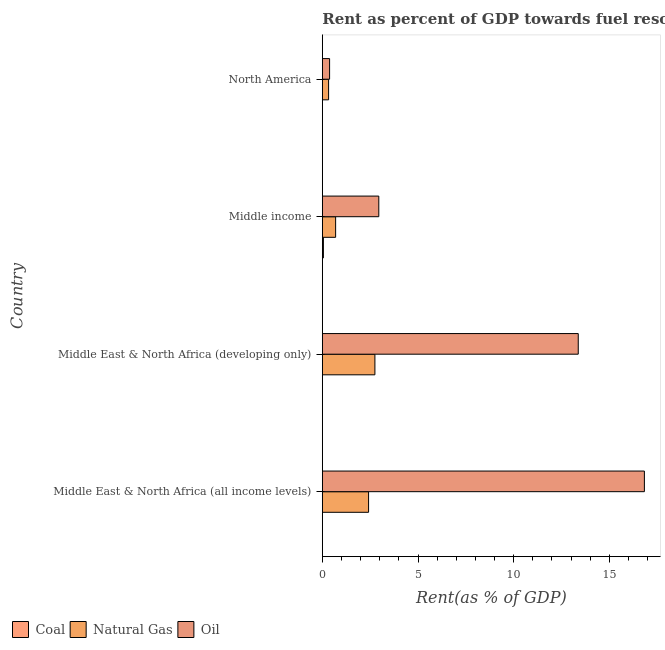How many groups of bars are there?
Your answer should be very brief. 4. How many bars are there on the 1st tick from the bottom?
Keep it short and to the point. 3. What is the label of the 4th group of bars from the top?
Provide a short and direct response. Middle East & North Africa (all income levels). What is the rent towards coal in North America?
Your answer should be very brief. 0. Across all countries, what is the maximum rent towards oil?
Your answer should be very brief. 16.83. Across all countries, what is the minimum rent towards oil?
Your answer should be compact. 0.38. In which country was the rent towards oil maximum?
Ensure brevity in your answer.  Middle East & North Africa (all income levels). In which country was the rent towards coal minimum?
Give a very brief answer. Middle East & North Africa (all income levels). What is the total rent towards coal in the graph?
Your answer should be compact. 0.06. What is the difference between the rent towards natural gas in Middle East & North Africa (all income levels) and that in Middle income?
Make the answer very short. 1.72. What is the difference between the rent towards oil in Middle income and the rent towards coal in Middle East & North Africa (developing only)?
Your answer should be compact. 2.95. What is the average rent towards natural gas per country?
Provide a short and direct response. 1.55. What is the difference between the rent towards oil and rent towards natural gas in Middle East & North Africa (developing only)?
Provide a short and direct response. 10.63. In how many countries, is the rent towards coal greater than 7 %?
Give a very brief answer. 0. What is the ratio of the rent towards oil in Middle income to that in North America?
Your response must be concise. 7.77. Is the difference between the rent towards oil in Middle East & North Africa (all income levels) and Middle income greater than the difference between the rent towards natural gas in Middle East & North Africa (all income levels) and Middle income?
Keep it short and to the point. Yes. What is the difference between the highest and the second highest rent towards oil?
Your answer should be compact. 3.46. In how many countries, is the rent towards coal greater than the average rent towards coal taken over all countries?
Keep it short and to the point. 1. Is the sum of the rent towards oil in Middle East & North Africa (all income levels) and Middle East & North Africa (developing only) greater than the maximum rent towards coal across all countries?
Make the answer very short. Yes. What does the 2nd bar from the top in Middle income represents?
Keep it short and to the point. Natural Gas. What does the 3rd bar from the bottom in North America represents?
Your answer should be very brief. Oil. How many bars are there?
Your answer should be very brief. 12. Are all the bars in the graph horizontal?
Your answer should be compact. Yes. How many countries are there in the graph?
Offer a very short reply. 4. Are the values on the major ticks of X-axis written in scientific E-notation?
Make the answer very short. No. Where does the legend appear in the graph?
Keep it short and to the point. Bottom left. What is the title of the graph?
Provide a short and direct response. Rent as percent of GDP towards fuel resources of different countries in 1997. Does "Labor Tax" appear as one of the legend labels in the graph?
Your answer should be very brief. No. What is the label or title of the X-axis?
Your answer should be very brief. Rent(as % of GDP). What is the Rent(as % of GDP) of Coal in Middle East & North Africa (all income levels)?
Provide a short and direct response. 0. What is the Rent(as % of GDP) of Natural Gas in Middle East & North Africa (all income levels)?
Offer a terse response. 2.42. What is the Rent(as % of GDP) in Oil in Middle East & North Africa (all income levels)?
Keep it short and to the point. 16.83. What is the Rent(as % of GDP) of Coal in Middle East & North Africa (developing only)?
Ensure brevity in your answer.  0. What is the Rent(as % of GDP) of Natural Gas in Middle East & North Africa (developing only)?
Offer a terse response. 2.75. What is the Rent(as % of GDP) of Oil in Middle East & North Africa (developing only)?
Give a very brief answer. 13.37. What is the Rent(as % of GDP) in Coal in Middle income?
Keep it short and to the point. 0.06. What is the Rent(as % of GDP) in Natural Gas in Middle income?
Give a very brief answer. 0.69. What is the Rent(as % of GDP) of Oil in Middle income?
Offer a terse response. 2.95. What is the Rent(as % of GDP) in Coal in North America?
Give a very brief answer. 0. What is the Rent(as % of GDP) in Natural Gas in North America?
Give a very brief answer. 0.33. What is the Rent(as % of GDP) of Oil in North America?
Make the answer very short. 0.38. Across all countries, what is the maximum Rent(as % of GDP) of Coal?
Provide a succinct answer. 0.06. Across all countries, what is the maximum Rent(as % of GDP) in Natural Gas?
Ensure brevity in your answer.  2.75. Across all countries, what is the maximum Rent(as % of GDP) of Oil?
Offer a very short reply. 16.83. Across all countries, what is the minimum Rent(as % of GDP) in Coal?
Your answer should be very brief. 0. Across all countries, what is the minimum Rent(as % of GDP) of Natural Gas?
Your answer should be very brief. 0.33. Across all countries, what is the minimum Rent(as % of GDP) of Oil?
Give a very brief answer. 0.38. What is the total Rent(as % of GDP) of Coal in the graph?
Make the answer very short. 0.06. What is the total Rent(as % of GDP) in Natural Gas in the graph?
Give a very brief answer. 6.19. What is the total Rent(as % of GDP) in Oil in the graph?
Give a very brief answer. 33.53. What is the difference between the Rent(as % of GDP) in Coal in Middle East & North Africa (all income levels) and that in Middle East & North Africa (developing only)?
Give a very brief answer. -0. What is the difference between the Rent(as % of GDP) of Natural Gas in Middle East & North Africa (all income levels) and that in Middle East & North Africa (developing only)?
Offer a terse response. -0.33. What is the difference between the Rent(as % of GDP) of Oil in Middle East & North Africa (all income levels) and that in Middle East & North Africa (developing only)?
Provide a succinct answer. 3.46. What is the difference between the Rent(as % of GDP) in Coal in Middle East & North Africa (all income levels) and that in Middle income?
Keep it short and to the point. -0.06. What is the difference between the Rent(as % of GDP) of Natural Gas in Middle East & North Africa (all income levels) and that in Middle income?
Give a very brief answer. 1.72. What is the difference between the Rent(as % of GDP) of Oil in Middle East & North Africa (all income levels) and that in Middle income?
Offer a very short reply. 13.88. What is the difference between the Rent(as % of GDP) of Coal in Middle East & North Africa (all income levels) and that in North America?
Your answer should be very brief. -0. What is the difference between the Rent(as % of GDP) of Natural Gas in Middle East & North Africa (all income levels) and that in North America?
Provide a succinct answer. 2.09. What is the difference between the Rent(as % of GDP) of Oil in Middle East & North Africa (all income levels) and that in North America?
Offer a terse response. 16.45. What is the difference between the Rent(as % of GDP) of Coal in Middle East & North Africa (developing only) and that in Middle income?
Your response must be concise. -0.05. What is the difference between the Rent(as % of GDP) in Natural Gas in Middle East & North Africa (developing only) and that in Middle income?
Your answer should be compact. 2.05. What is the difference between the Rent(as % of GDP) of Oil in Middle East & North Africa (developing only) and that in Middle income?
Provide a short and direct response. 10.42. What is the difference between the Rent(as % of GDP) of Coal in Middle East & North Africa (developing only) and that in North America?
Keep it short and to the point. -0. What is the difference between the Rent(as % of GDP) in Natural Gas in Middle East & North Africa (developing only) and that in North America?
Give a very brief answer. 2.42. What is the difference between the Rent(as % of GDP) in Oil in Middle East & North Africa (developing only) and that in North America?
Your answer should be very brief. 12.99. What is the difference between the Rent(as % of GDP) in Coal in Middle income and that in North America?
Give a very brief answer. 0.05. What is the difference between the Rent(as % of GDP) of Natural Gas in Middle income and that in North America?
Your response must be concise. 0.37. What is the difference between the Rent(as % of GDP) of Oil in Middle income and that in North America?
Your answer should be compact. 2.57. What is the difference between the Rent(as % of GDP) of Coal in Middle East & North Africa (all income levels) and the Rent(as % of GDP) of Natural Gas in Middle East & North Africa (developing only)?
Give a very brief answer. -2.75. What is the difference between the Rent(as % of GDP) in Coal in Middle East & North Africa (all income levels) and the Rent(as % of GDP) in Oil in Middle East & North Africa (developing only)?
Make the answer very short. -13.37. What is the difference between the Rent(as % of GDP) in Natural Gas in Middle East & North Africa (all income levels) and the Rent(as % of GDP) in Oil in Middle East & North Africa (developing only)?
Your answer should be very brief. -10.96. What is the difference between the Rent(as % of GDP) of Coal in Middle East & North Africa (all income levels) and the Rent(as % of GDP) of Natural Gas in Middle income?
Your answer should be compact. -0.69. What is the difference between the Rent(as % of GDP) of Coal in Middle East & North Africa (all income levels) and the Rent(as % of GDP) of Oil in Middle income?
Provide a succinct answer. -2.95. What is the difference between the Rent(as % of GDP) in Natural Gas in Middle East & North Africa (all income levels) and the Rent(as % of GDP) in Oil in Middle income?
Provide a short and direct response. -0.53. What is the difference between the Rent(as % of GDP) of Coal in Middle East & North Africa (all income levels) and the Rent(as % of GDP) of Natural Gas in North America?
Your answer should be very brief. -0.33. What is the difference between the Rent(as % of GDP) of Coal in Middle East & North Africa (all income levels) and the Rent(as % of GDP) of Oil in North America?
Ensure brevity in your answer.  -0.38. What is the difference between the Rent(as % of GDP) in Natural Gas in Middle East & North Africa (all income levels) and the Rent(as % of GDP) in Oil in North America?
Offer a very short reply. 2.04. What is the difference between the Rent(as % of GDP) of Coal in Middle East & North Africa (developing only) and the Rent(as % of GDP) of Natural Gas in Middle income?
Offer a terse response. -0.69. What is the difference between the Rent(as % of GDP) in Coal in Middle East & North Africa (developing only) and the Rent(as % of GDP) in Oil in Middle income?
Ensure brevity in your answer.  -2.95. What is the difference between the Rent(as % of GDP) of Natural Gas in Middle East & North Africa (developing only) and the Rent(as % of GDP) of Oil in Middle income?
Your answer should be very brief. -0.2. What is the difference between the Rent(as % of GDP) in Coal in Middle East & North Africa (developing only) and the Rent(as % of GDP) in Natural Gas in North America?
Ensure brevity in your answer.  -0.33. What is the difference between the Rent(as % of GDP) of Coal in Middle East & North Africa (developing only) and the Rent(as % of GDP) of Oil in North America?
Your response must be concise. -0.38. What is the difference between the Rent(as % of GDP) in Natural Gas in Middle East & North Africa (developing only) and the Rent(as % of GDP) in Oil in North America?
Provide a short and direct response. 2.37. What is the difference between the Rent(as % of GDP) in Coal in Middle income and the Rent(as % of GDP) in Natural Gas in North America?
Provide a succinct answer. -0.27. What is the difference between the Rent(as % of GDP) in Coal in Middle income and the Rent(as % of GDP) in Oil in North America?
Ensure brevity in your answer.  -0.32. What is the difference between the Rent(as % of GDP) of Natural Gas in Middle income and the Rent(as % of GDP) of Oil in North America?
Offer a terse response. 0.32. What is the average Rent(as % of GDP) in Coal per country?
Make the answer very short. 0.02. What is the average Rent(as % of GDP) of Natural Gas per country?
Your response must be concise. 1.55. What is the average Rent(as % of GDP) of Oil per country?
Provide a succinct answer. 8.38. What is the difference between the Rent(as % of GDP) of Coal and Rent(as % of GDP) of Natural Gas in Middle East & North Africa (all income levels)?
Your response must be concise. -2.42. What is the difference between the Rent(as % of GDP) in Coal and Rent(as % of GDP) in Oil in Middle East & North Africa (all income levels)?
Ensure brevity in your answer.  -16.83. What is the difference between the Rent(as % of GDP) of Natural Gas and Rent(as % of GDP) of Oil in Middle East & North Africa (all income levels)?
Offer a very short reply. -14.41. What is the difference between the Rent(as % of GDP) of Coal and Rent(as % of GDP) of Natural Gas in Middle East & North Africa (developing only)?
Offer a very short reply. -2.75. What is the difference between the Rent(as % of GDP) in Coal and Rent(as % of GDP) in Oil in Middle East & North Africa (developing only)?
Give a very brief answer. -13.37. What is the difference between the Rent(as % of GDP) in Natural Gas and Rent(as % of GDP) in Oil in Middle East & North Africa (developing only)?
Your response must be concise. -10.63. What is the difference between the Rent(as % of GDP) in Coal and Rent(as % of GDP) in Natural Gas in Middle income?
Your answer should be compact. -0.64. What is the difference between the Rent(as % of GDP) in Coal and Rent(as % of GDP) in Oil in Middle income?
Provide a succinct answer. -2.9. What is the difference between the Rent(as % of GDP) of Natural Gas and Rent(as % of GDP) of Oil in Middle income?
Provide a short and direct response. -2.26. What is the difference between the Rent(as % of GDP) of Coal and Rent(as % of GDP) of Natural Gas in North America?
Your answer should be compact. -0.32. What is the difference between the Rent(as % of GDP) of Coal and Rent(as % of GDP) of Oil in North America?
Make the answer very short. -0.37. What is the difference between the Rent(as % of GDP) of Natural Gas and Rent(as % of GDP) of Oil in North America?
Offer a terse response. -0.05. What is the ratio of the Rent(as % of GDP) in Coal in Middle East & North Africa (all income levels) to that in Middle East & North Africa (developing only)?
Provide a succinct answer. 0.47. What is the ratio of the Rent(as % of GDP) of Natural Gas in Middle East & North Africa (all income levels) to that in Middle East & North Africa (developing only)?
Provide a short and direct response. 0.88. What is the ratio of the Rent(as % of GDP) in Oil in Middle East & North Africa (all income levels) to that in Middle East & North Africa (developing only)?
Give a very brief answer. 1.26. What is the ratio of the Rent(as % of GDP) of Coal in Middle East & North Africa (all income levels) to that in Middle income?
Provide a succinct answer. 0.02. What is the ratio of the Rent(as % of GDP) in Natural Gas in Middle East & North Africa (all income levels) to that in Middle income?
Your response must be concise. 3.48. What is the ratio of the Rent(as % of GDP) in Oil in Middle East & North Africa (all income levels) to that in Middle income?
Make the answer very short. 5.7. What is the ratio of the Rent(as % of GDP) of Coal in Middle East & North Africa (all income levels) to that in North America?
Offer a terse response. 0.2. What is the ratio of the Rent(as % of GDP) of Natural Gas in Middle East & North Africa (all income levels) to that in North America?
Give a very brief answer. 7.38. What is the ratio of the Rent(as % of GDP) in Oil in Middle East & North Africa (all income levels) to that in North America?
Offer a terse response. 44.34. What is the ratio of the Rent(as % of GDP) in Coal in Middle East & North Africa (developing only) to that in Middle income?
Keep it short and to the point. 0.04. What is the ratio of the Rent(as % of GDP) of Natural Gas in Middle East & North Africa (developing only) to that in Middle income?
Keep it short and to the point. 3.95. What is the ratio of the Rent(as % of GDP) in Oil in Middle East & North Africa (developing only) to that in Middle income?
Ensure brevity in your answer.  4.53. What is the ratio of the Rent(as % of GDP) of Coal in Middle East & North Africa (developing only) to that in North America?
Provide a succinct answer. 0.42. What is the ratio of the Rent(as % of GDP) of Natural Gas in Middle East & North Africa (developing only) to that in North America?
Ensure brevity in your answer.  8.38. What is the ratio of the Rent(as % of GDP) of Oil in Middle East & North Africa (developing only) to that in North America?
Your answer should be compact. 35.23. What is the ratio of the Rent(as % of GDP) of Coal in Middle income to that in North America?
Your answer should be compact. 11.85. What is the ratio of the Rent(as % of GDP) of Natural Gas in Middle income to that in North America?
Offer a very short reply. 2.12. What is the ratio of the Rent(as % of GDP) of Oil in Middle income to that in North America?
Keep it short and to the point. 7.77. What is the difference between the highest and the second highest Rent(as % of GDP) of Coal?
Keep it short and to the point. 0.05. What is the difference between the highest and the second highest Rent(as % of GDP) of Natural Gas?
Provide a succinct answer. 0.33. What is the difference between the highest and the second highest Rent(as % of GDP) in Oil?
Give a very brief answer. 3.46. What is the difference between the highest and the lowest Rent(as % of GDP) of Coal?
Provide a short and direct response. 0.06. What is the difference between the highest and the lowest Rent(as % of GDP) in Natural Gas?
Keep it short and to the point. 2.42. What is the difference between the highest and the lowest Rent(as % of GDP) of Oil?
Offer a very short reply. 16.45. 